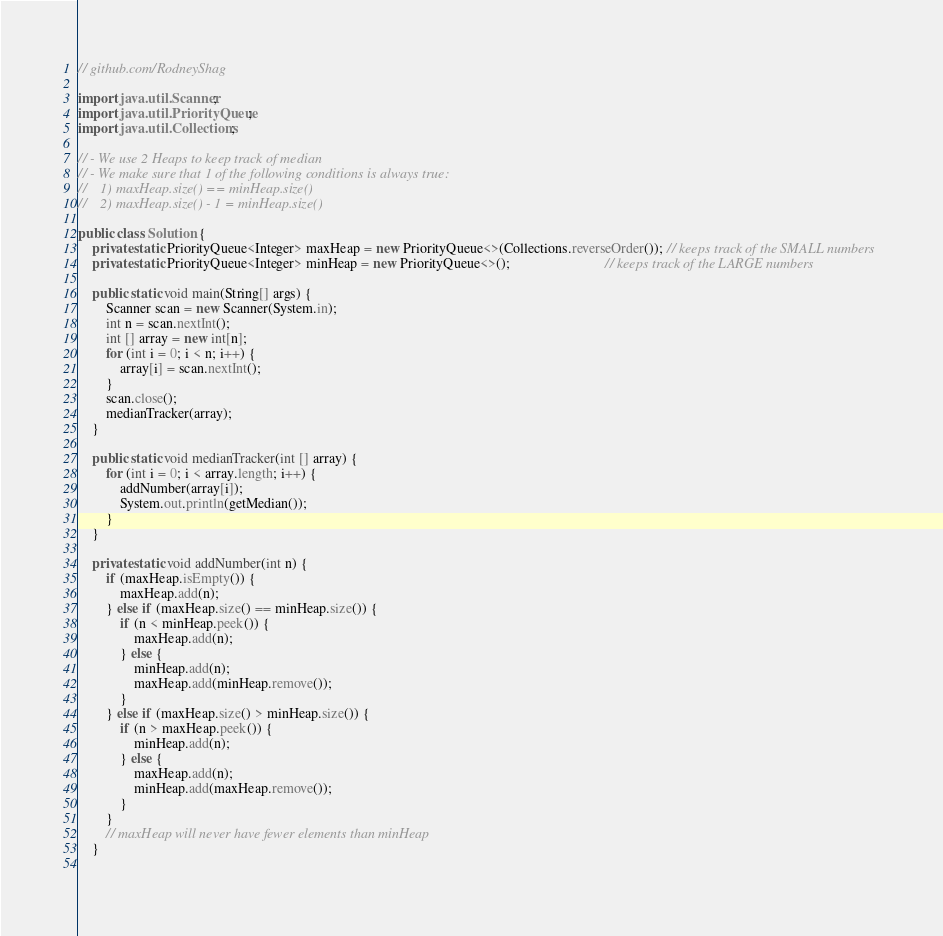<code> <loc_0><loc_0><loc_500><loc_500><_Java_>// github.com/RodneyShag

import java.util.Scanner;
import java.util.PriorityQueue;
import java.util.Collections;

// - We use 2 Heaps to keep track of median
// - We make sure that 1 of the following conditions is always true:
//    1) maxHeap.size() == minHeap.size()
//    2) maxHeap.size() - 1 = minHeap.size()

public class Solution {
    private static PriorityQueue<Integer> maxHeap = new PriorityQueue<>(Collections.reverseOrder()); // keeps track of the SMALL numbers
    private static PriorityQueue<Integer> minHeap = new PriorityQueue<>();                           // keeps track of the LARGE numbers
    
    public static void main(String[] args) {
        Scanner scan = new Scanner(System.in);
        int n = scan.nextInt();
        int [] array = new int[n];
        for (int i = 0; i < n; i++) {
            array[i] = scan.nextInt();
        }
        scan.close();
        medianTracker(array);
    }
    
    public static void medianTracker(int [] array) {
        for (int i = 0; i < array.length; i++) {
            addNumber(array[i]);
            System.out.println(getMedian());
        }
    }
    
    private static void addNumber(int n) {
        if (maxHeap.isEmpty()) {
            maxHeap.add(n);
        } else if (maxHeap.size() == minHeap.size()) {
            if (n < minHeap.peek()) {
                maxHeap.add(n);
            } else {
                minHeap.add(n);
                maxHeap.add(minHeap.remove());
            }
        } else if (maxHeap.size() > minHeap.size()) {
            if (n > maxHeap.peek()) {
                minHeap.add(n);
            } else {
                maxHeap.add(n);
                minHeap.add(maxHeap.remove());
            }
        }
        // maxHeap will never have fewer elements than minHeap
    }
    </code> 